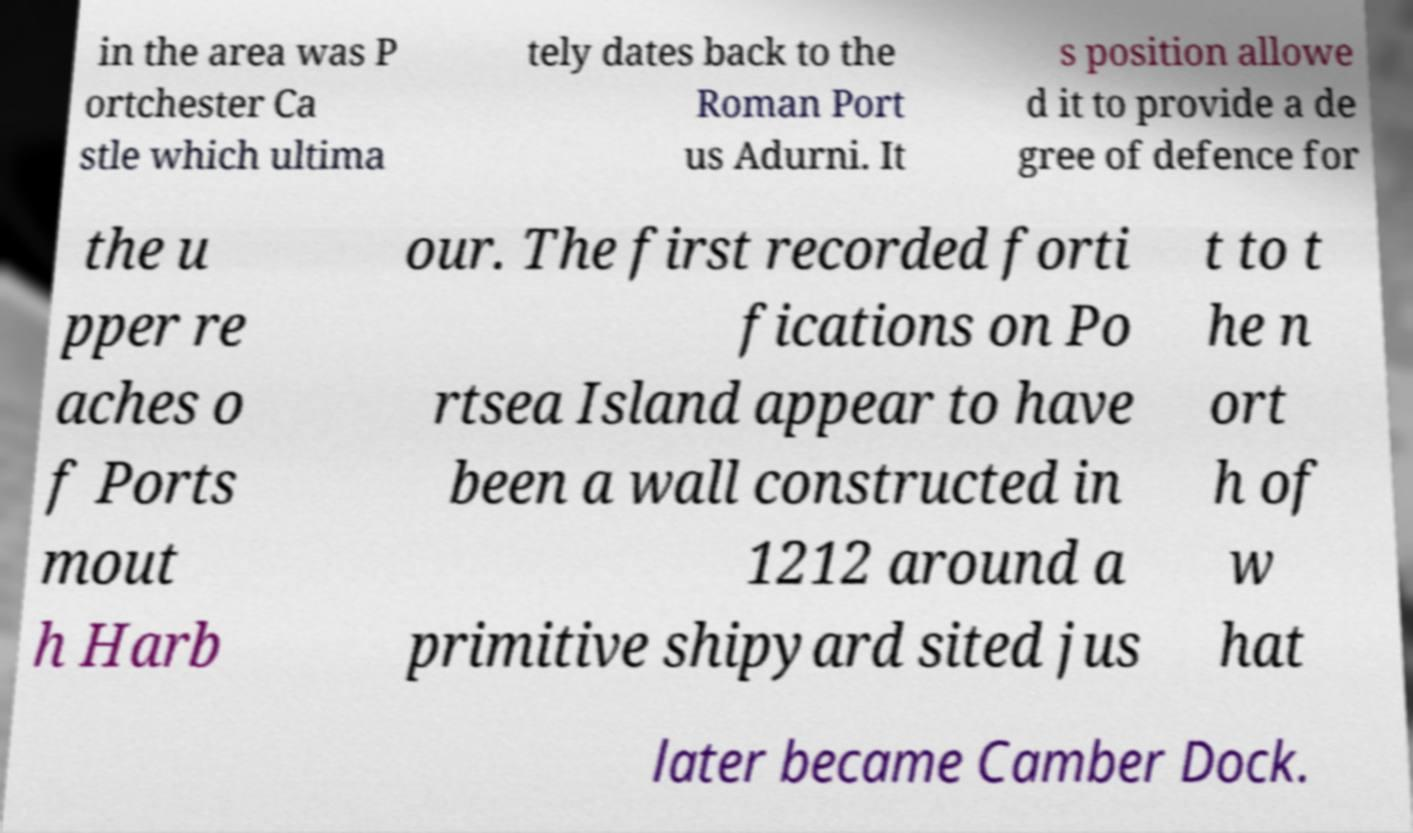Please read and relay the text visible in this image. What does it say? in the area was P ortchester Ca stle which ultima tely dates back to the Roman Port us Adurni. It s position allowe d it to provide a de gree of defence for the u pper re aches o f Ports mout h Harb our. The first recorded forti fications on Po rtsea Island appear to have been a wall constructed in 1212 around a primitive shipyard sited jus t to t he n ort h of w hat later became Camber Dock. 